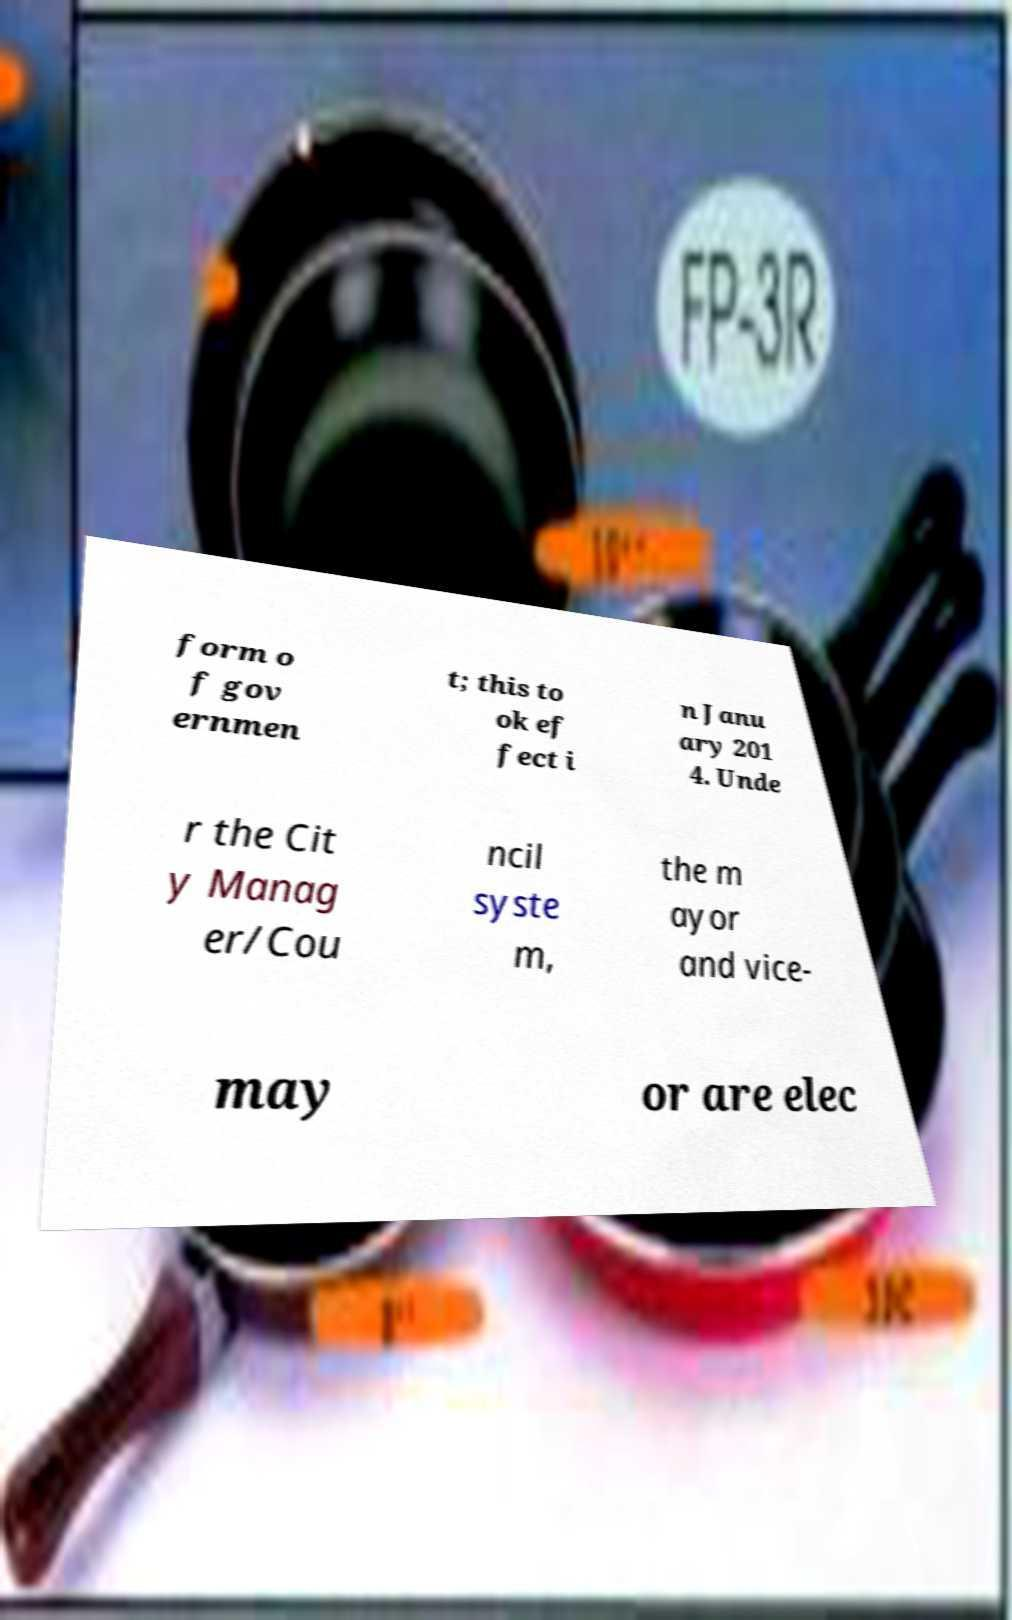Could you extract and type out the text from this image? form o f gov ernmen t; this to ok ef fect i n Janu ary 201 4. Unde r the Cit y Manag er/Cou ncil syste m, the m ayor and vice- may or are elec 